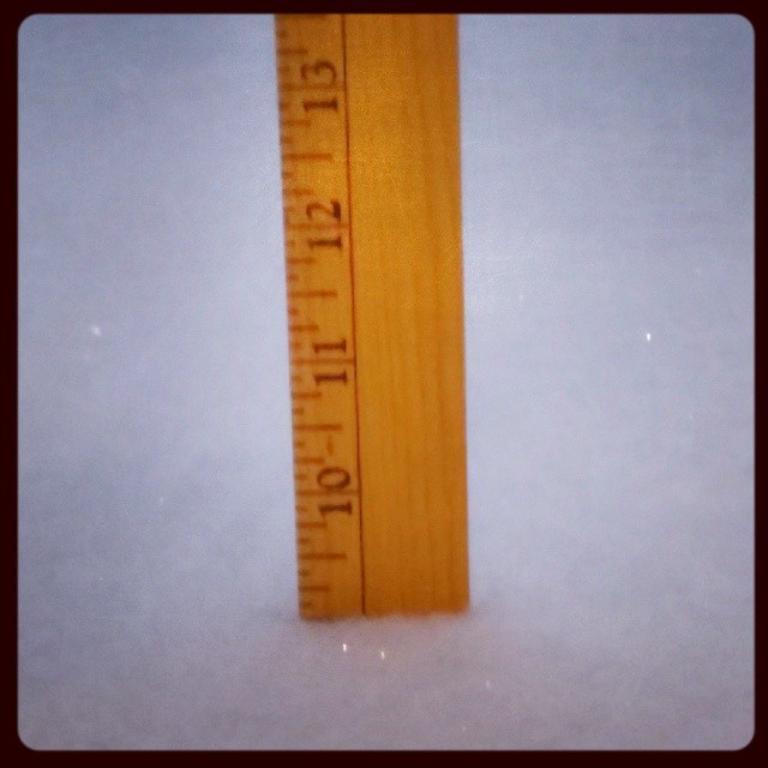What is the number slosest to the top?
Make the answer very short. 13. 